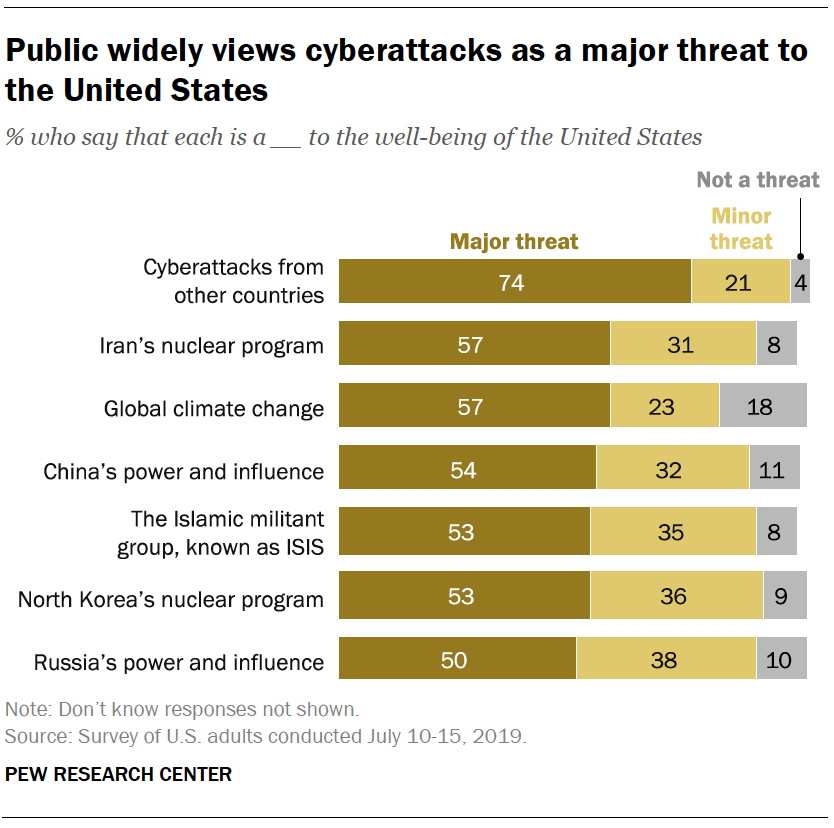Specify some key components in this picture. The "Cyberattacks from other countries" bar represents the most significant threat to the United States, with the largest value. The result of adding all the "major threat" values, then dividing by two is 199. 